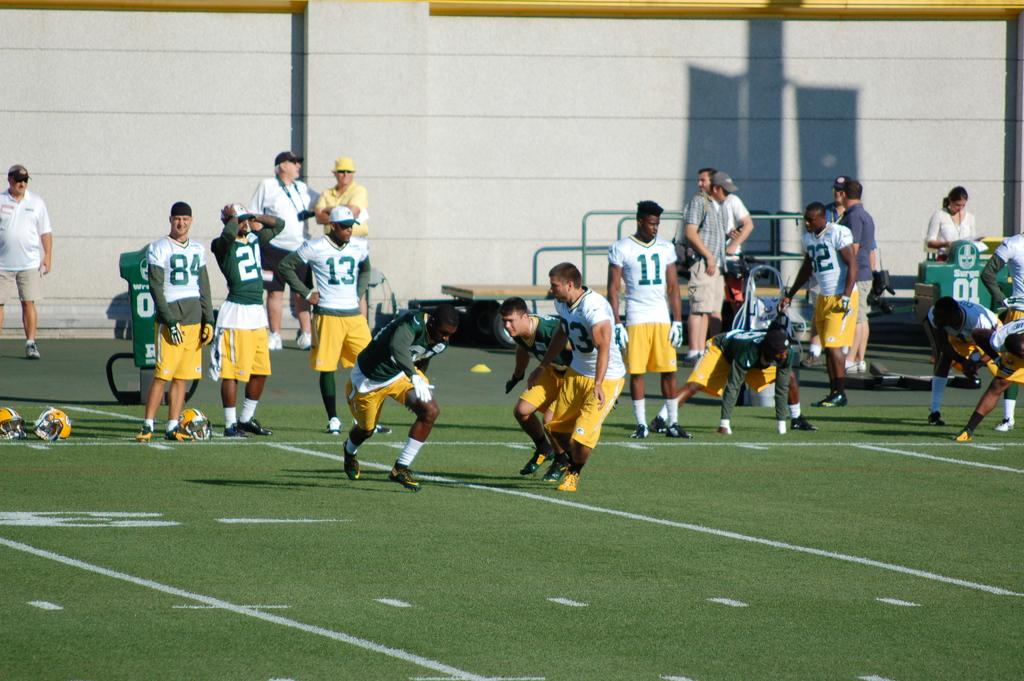<image>
Summarize the visual content of the image. People playing football on a field with the number 11 and 13 waiting on the sideline. 